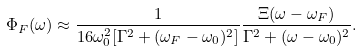Convert formula to latex. <formula><loc_0><loc_0><loc_500><loc_500>& \Phi _ { F } ( \omega ) \approx \frac { 1 } { 1 6 \omega _ { 0 } ^ { 2 } [ \Gamma ^ { 2 } + ( \omega _ { F } - \omega _ { 0 } ) ^ { 2 } ] } \frac { \Xi ( \omega - \omega _ { F } ) } { \Gamma ^ { 2 } + ( \omega - \omega _ { 0 } ) ^ { 2 } } .</formula> 